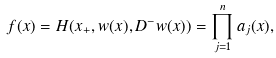Convert formula to latex. <formula><loc_0><loc_0><loc_500><loc_500>f ( x ) = H ( x _ { + } , w ( x ) , D ^ { - } w ( x ) ) = \prod _ { j = 1 } ^ { n } a _ { j } ( x ) ,</formula> 